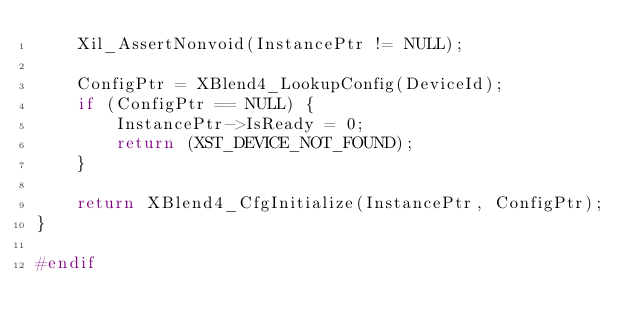<code> <loc_0><loc_0><loc_500><loc_500><_C_>	Xil_AssertNonvoid(InstancePtr != NULL);

	ConfigPtr = XBlend4_LookupConfig(DeviceId);
	if (ConfigPtr == NULL) {
		InstancePtr->IsReady = 0;
		return (XST_DEVICE_NOT_FOUND);
	}

	return XBlend4_CfgInitialize(InstancePtr, ConfigPtr);
}

#endif

</code> 